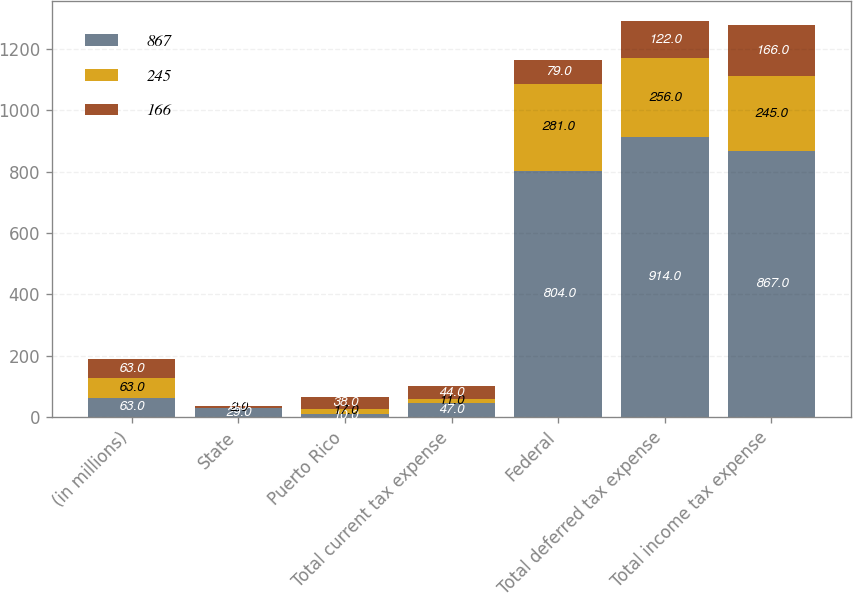<chart> <loc_0><loc_0><loc_500><loc_500><stacked_bar_chart><ecel><fcel>(in millions)<fcel>State<fcel>Puerto Rico<fcel>Total current tax expense<fcel>Federal<fcel>Total deferred tax expense<fcel>Total income tax expense<nl><fcel>867<fcel>63<fcel>29<fcel>10<fcel>47<fcel>804<fcel>914<fcel>867<nl><fcel>245<fcel>63<fcel>2<fcel>17<fcel>11<fcel>281<fcel>256<fcel>245<nl><fcel>166<fcel>63<fcel>6<fcel>38<fcel>44<fcel>79<fcel>122<fcel>166<nl></chart> 